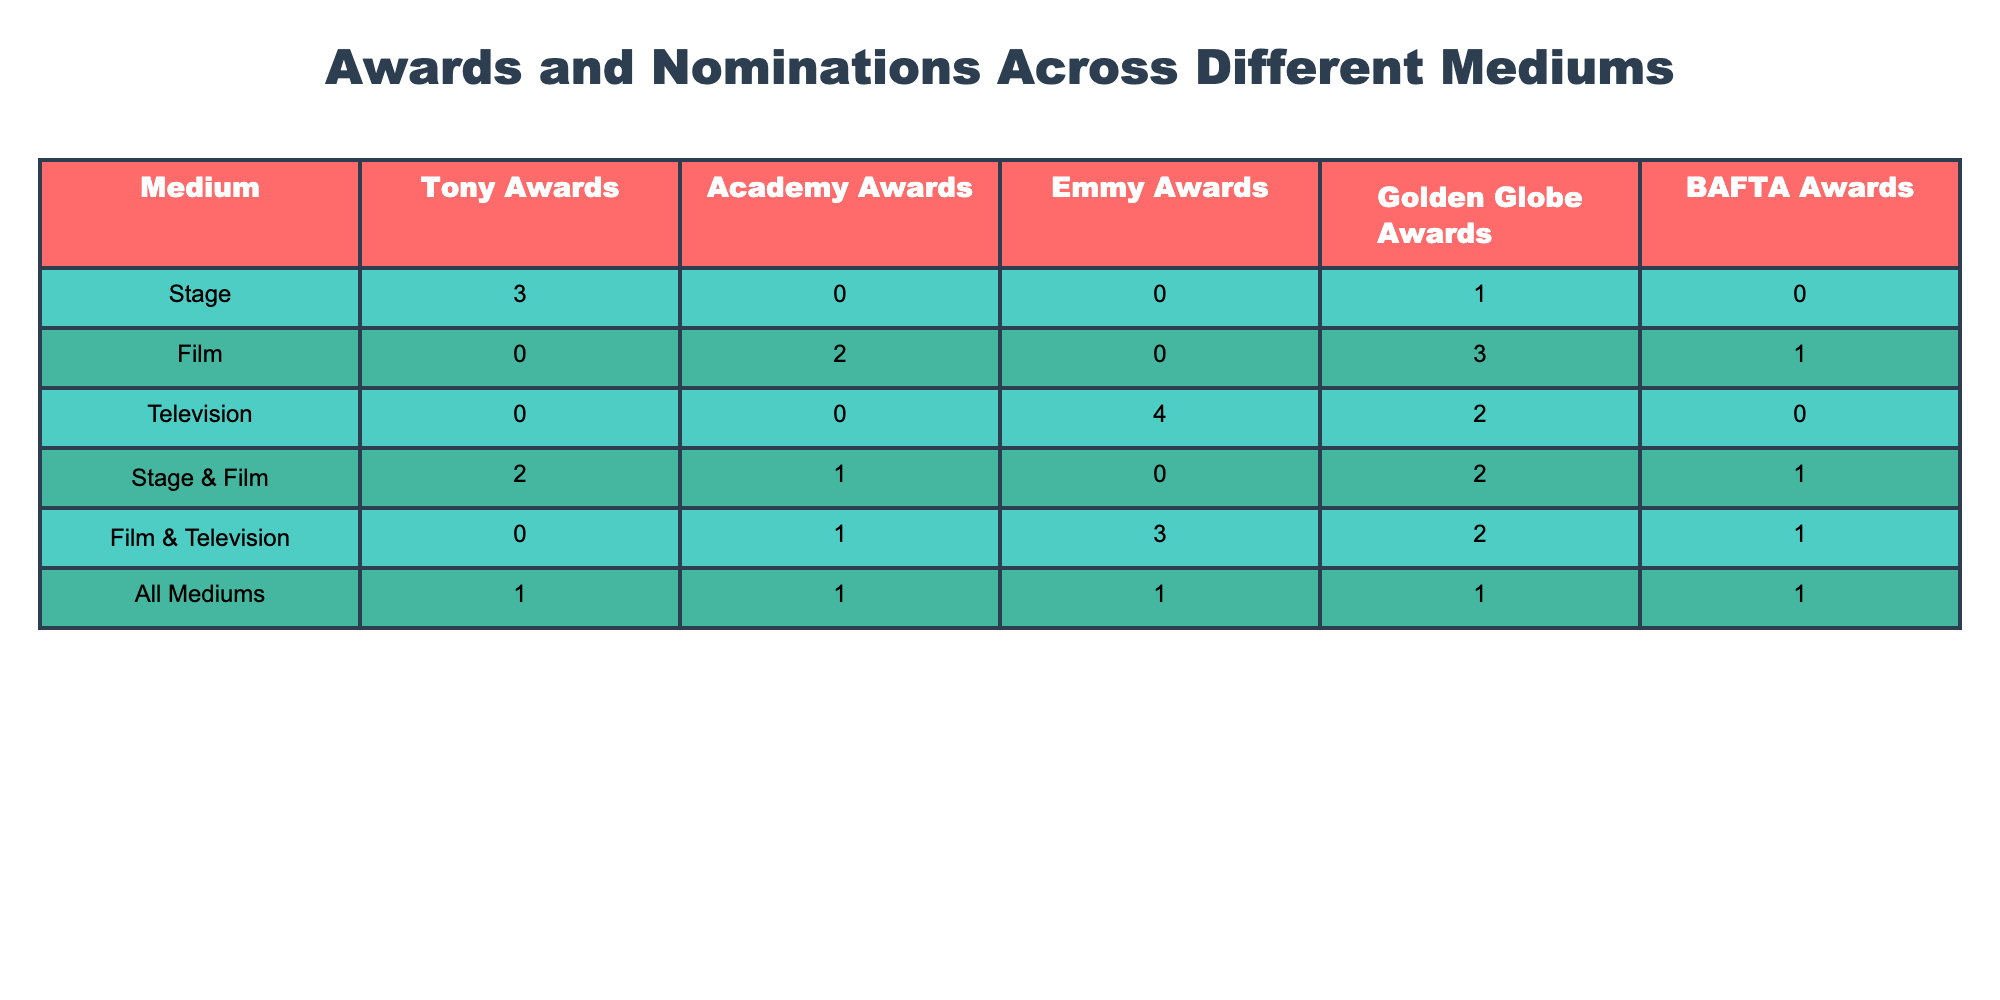What is the total number of Academy Awards across all mediums? To find the total number of Academy Awards, we sum the values in the "Academy Awards" column: 0 + 2 + 0 + 1 + 1 + 1 = 5.
Answer: 5 How many Emmy Awards did the "Stage & Film" category receive? According to the table, the "Stage & Film" category received 0 Emmy Awards.
Answer: 0 Which medium received the highest number of Golden Globe Awards? Looking at the "Golden Globe Awards" column, the Film medium received the highest with 3 awards.
Answer: Film Is it true that the Television medium received more Emmy Awards than the Film medium? The Television medium received 4 Emmy Awards, while the Film medium received 0, which supports the statement.
Answer: True What is the difference in the number of Tony Awards between Stage and "All Mediums"? The Stage received 3 Tony Awards and "All Mediums" received 1, thus the difference is 3 - 1 = 2.
Answer: 2 How many total awards does the "Film & Television" category have? We calculate the total by summing up all award categories for "Film & Television": 0 (Tony) + 1 (Academy) + 3 (Emmy) + 2 (Golden Globe) + 1 (BAFTA) = 7.
Answer: 7 In which categories did the Stage & Film receive awards? The Stage & Film category received awards in Tony Awards (2), Golden Globe Awards (2), and BAFTA Awards (1).
Answer: Tony, Golden Globe, BAFTA Which medium received the least number of BAFTA Awards? The Stage received 0 BAFTA Awards, which is the least in that column.
Answer: Stage What is the total number of awards received by the Television medium? For Television, we sum the awards: 0 (Tony) + 0 (Academy) + 4 (Emmy) + 2 (Golden Globe) + 0 (BAFTA) = 6.
Answer: 6 Is the number of Golden Globe Awards received by Film greater than that received by Television? Film received 3 Golden Globe Awards, while Television received 2, making the statement true.
Answer: True 